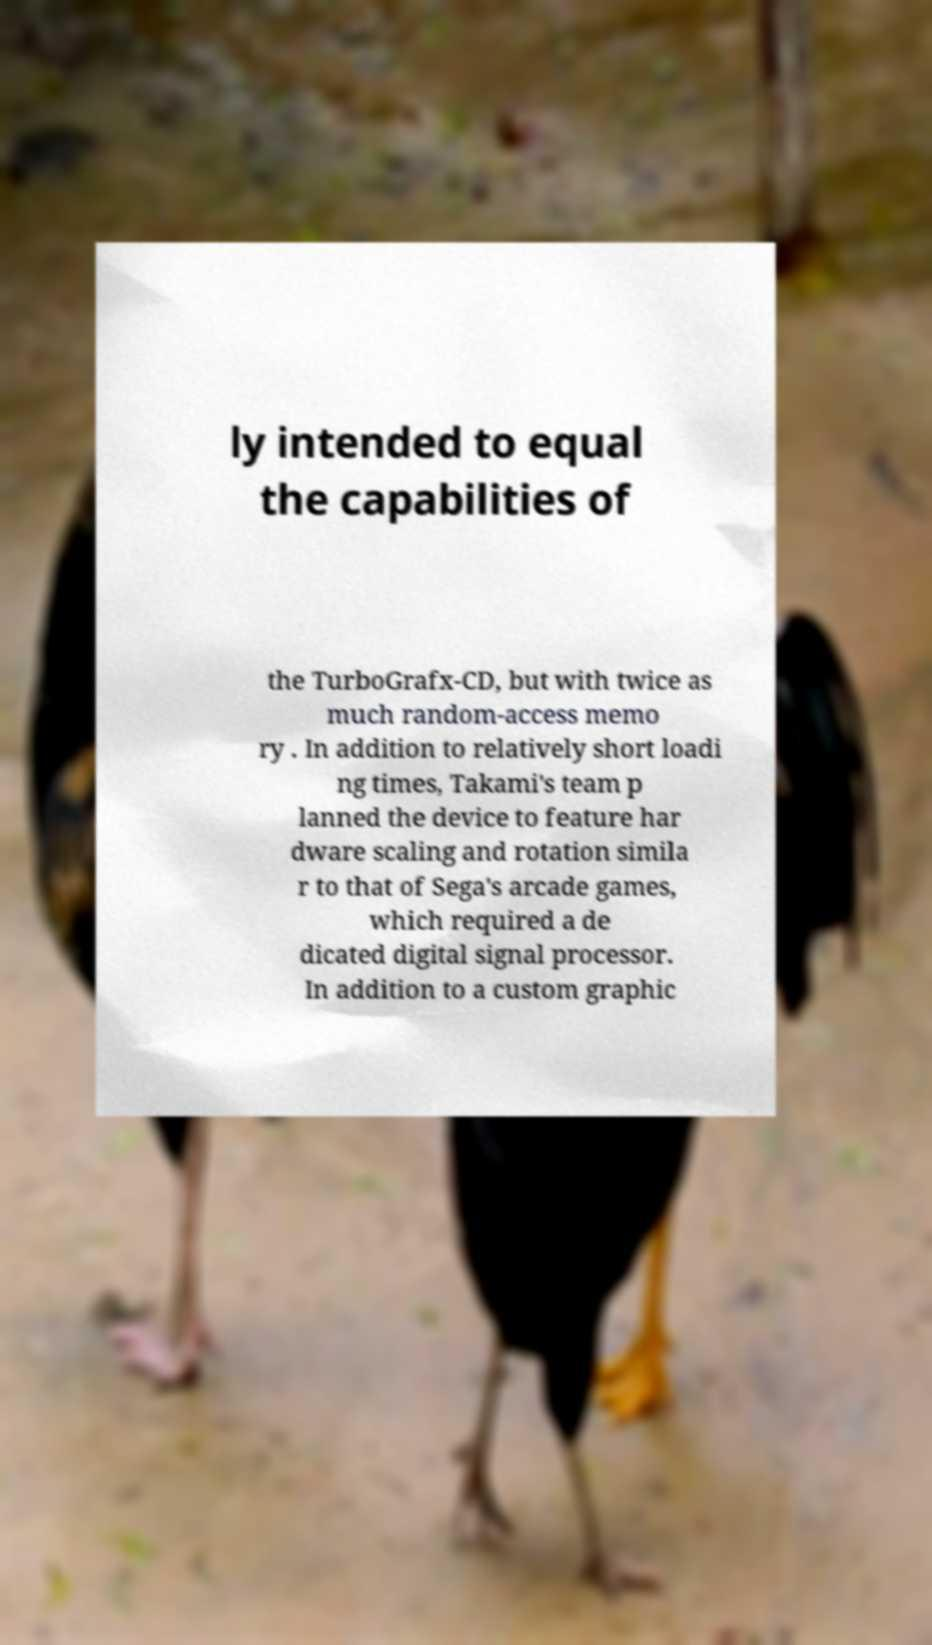Can you accurately transcribe the text from the provided image for me? ly intended to equal the capabilities of the TurboGrafx-CD, but with twice as much random-access memo ry . In addition to relatively short loadi ng times, Takami's team p lanned the device to feature har dware scaling and rotation simila r to that of Sega's arcade games, which required a de dicated digital signal processor. In addition to a custom graphic 